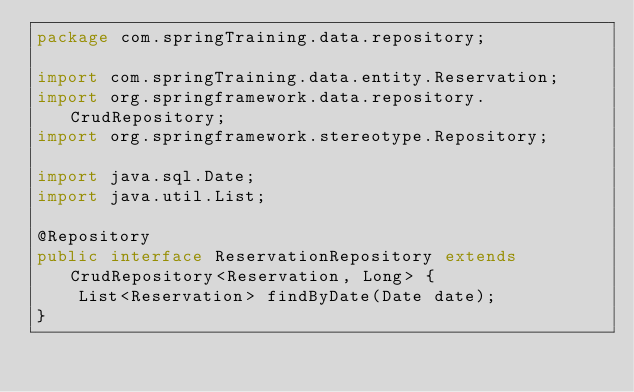<code> <loc_0><loc_0><loc_500><loc_500><_Java_>package com.springTraining.data.repository;

import com.springTraining.data.entity.Reservation;
import org.springframework.data.repository.CrudRepository;
import org.springframework.stereotype.Repository;

import java.sql.Date;
import java.util.List;

@Repository
public interface ReservationRepository extends CrudRepository<Reservation, Long> {
    List<Reservation> findByDate(Date date);
}</code> 